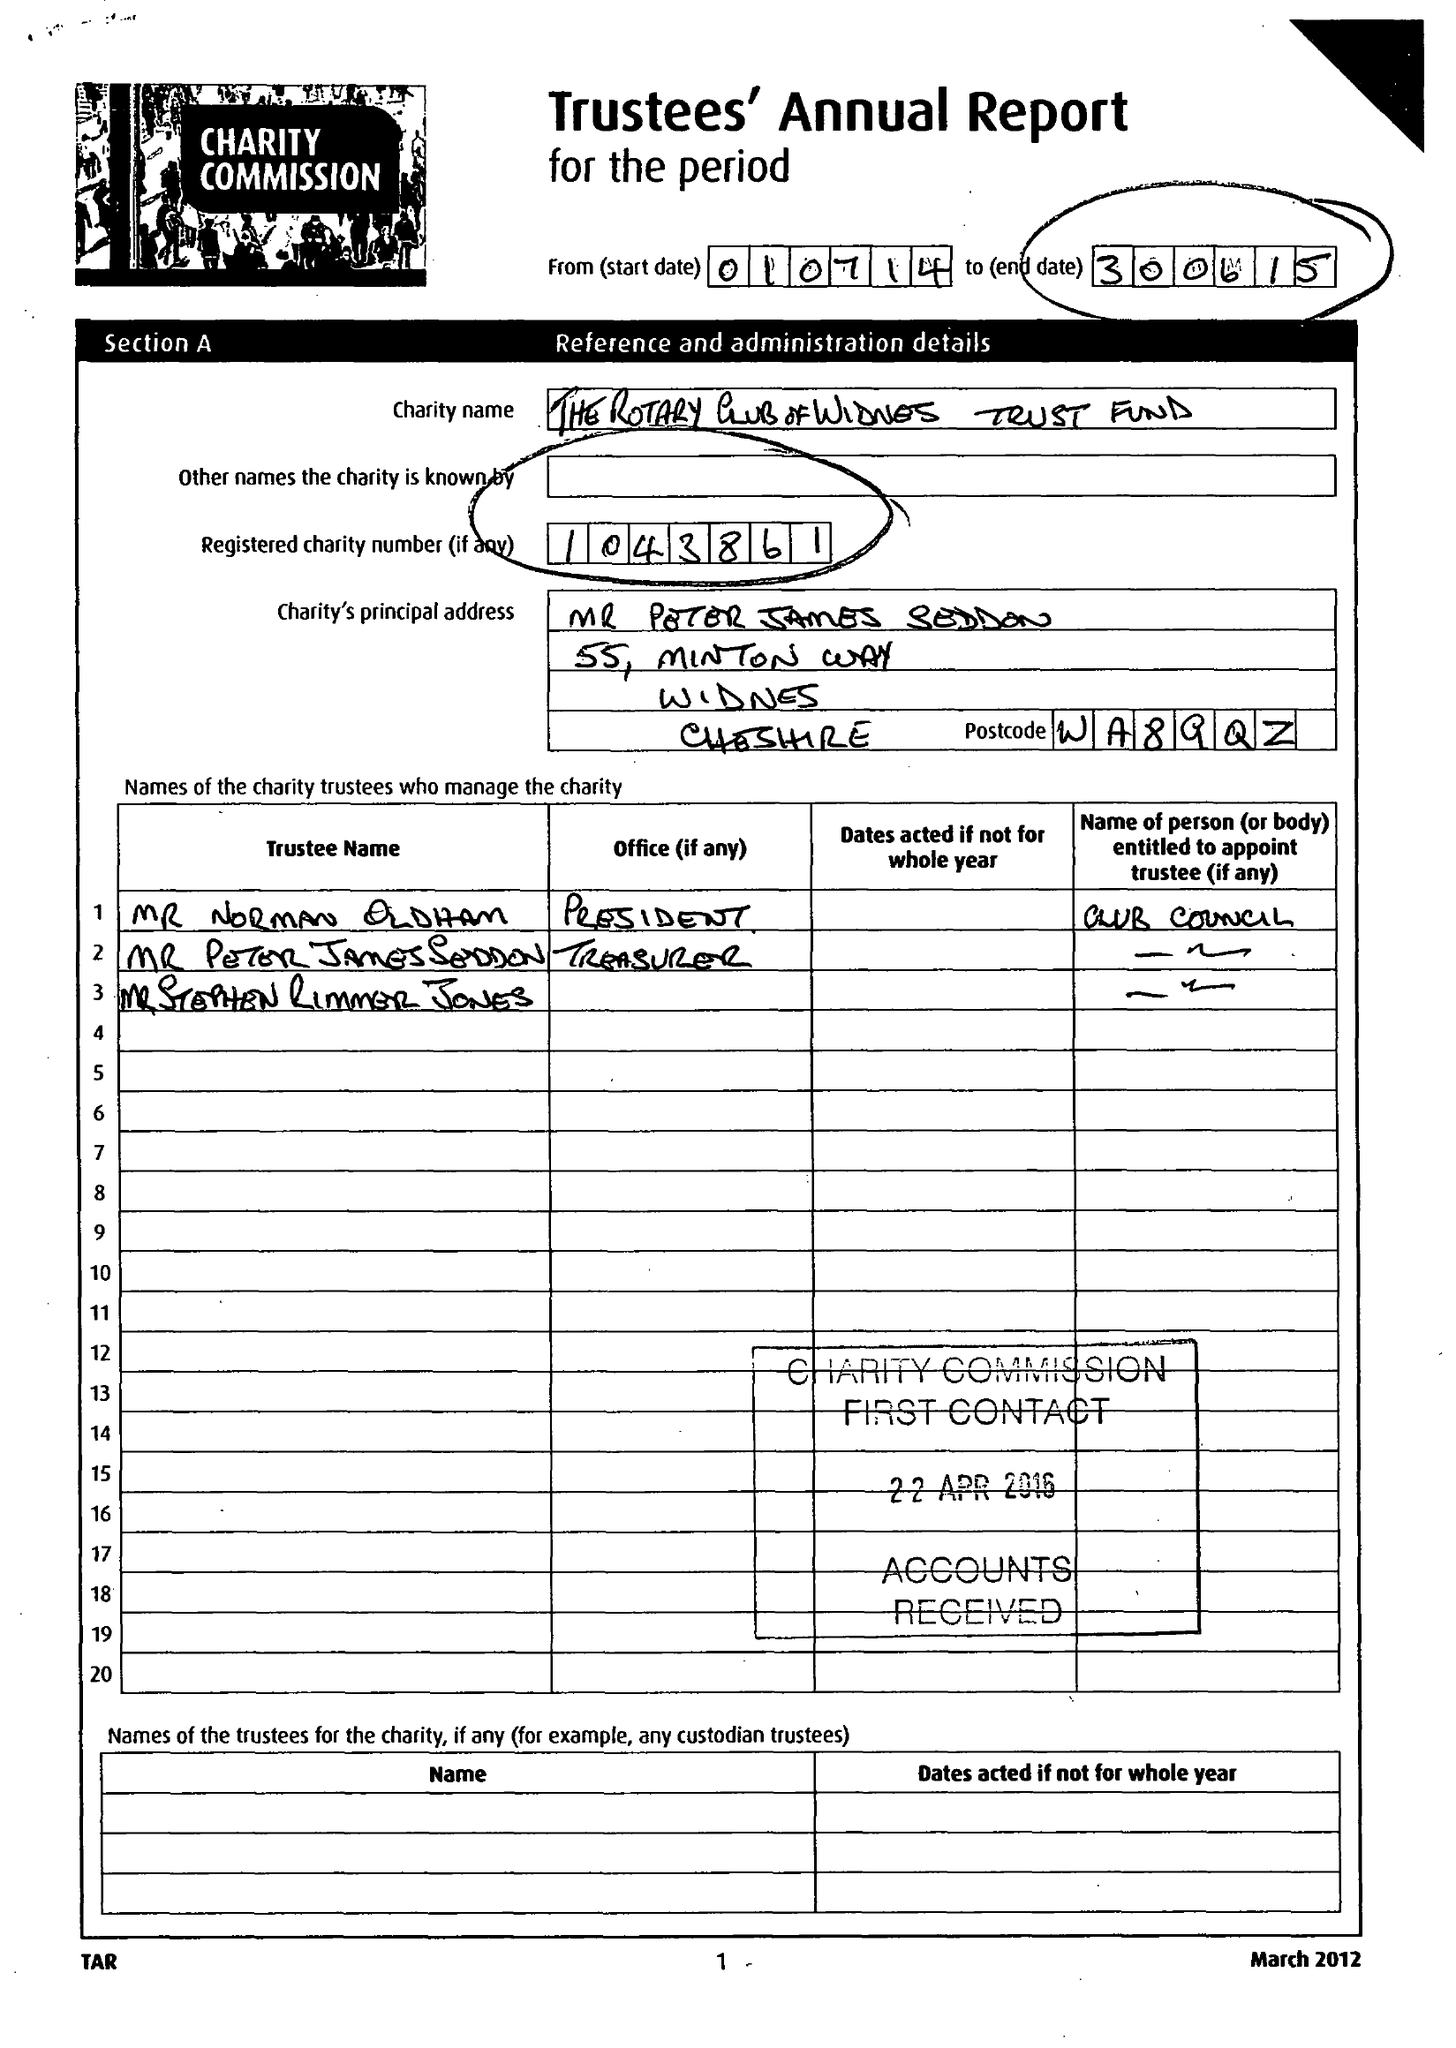What is the value for the report_date?
Answer the question using a single word or phrase. 2015-06-30 